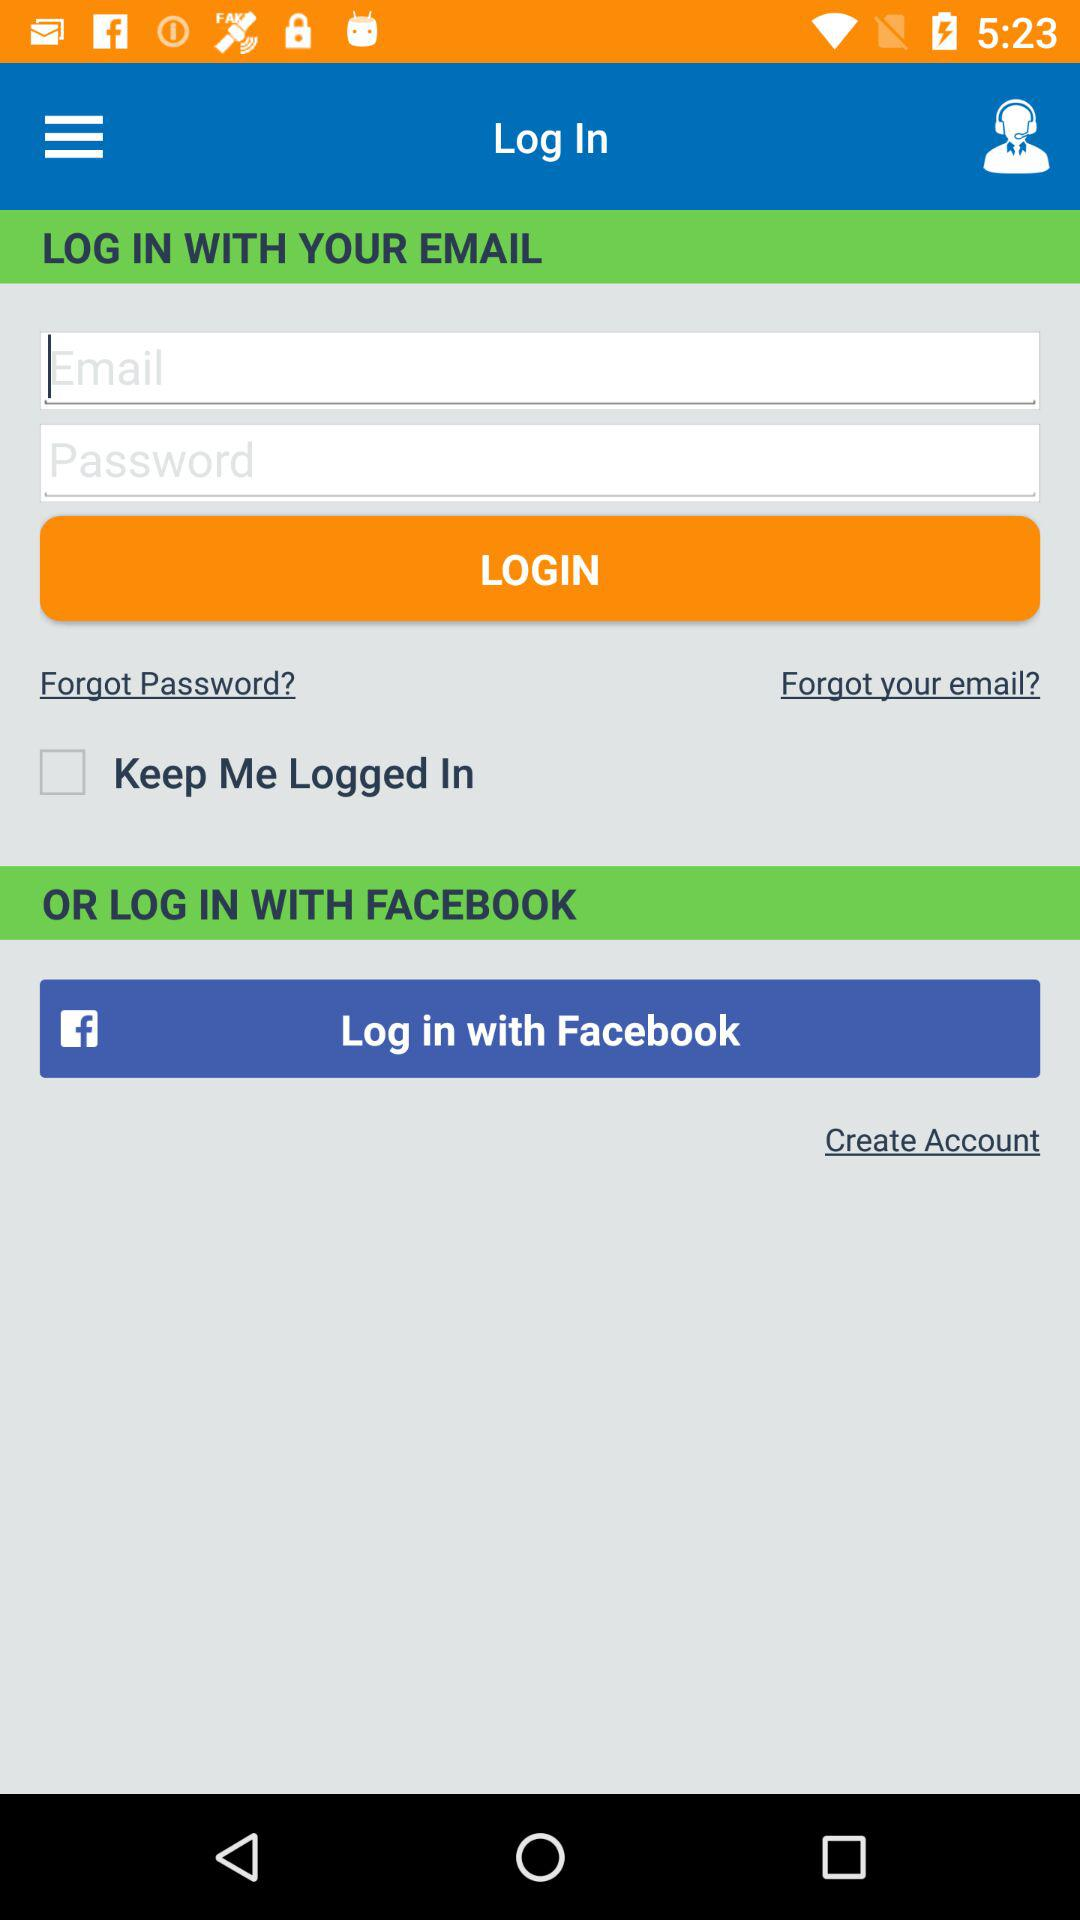What application can we use for logging in rather than email? The application that you can use for logging in rather than email is "Facebook". 